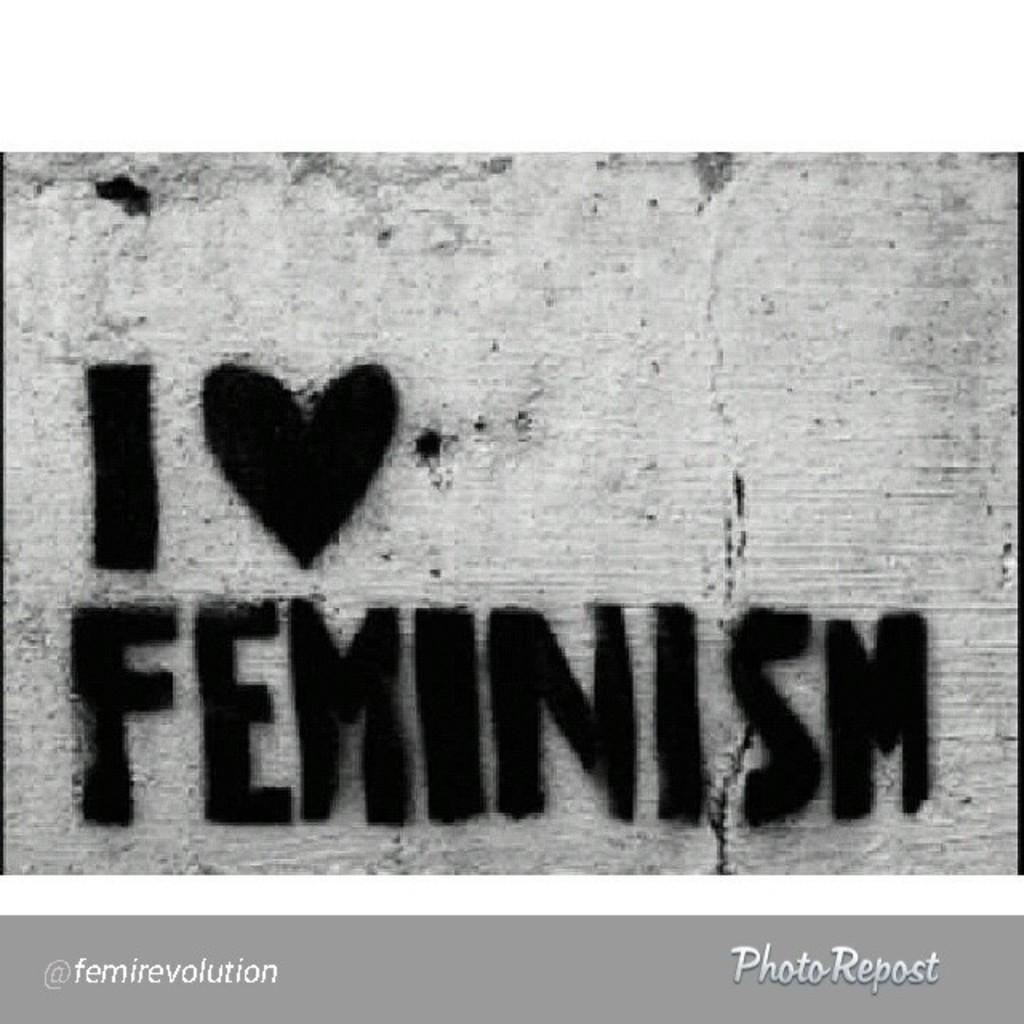Provide a one-sentence caption for the provided image. A spray painted stencil with black paint displays the message about loving feminism. 